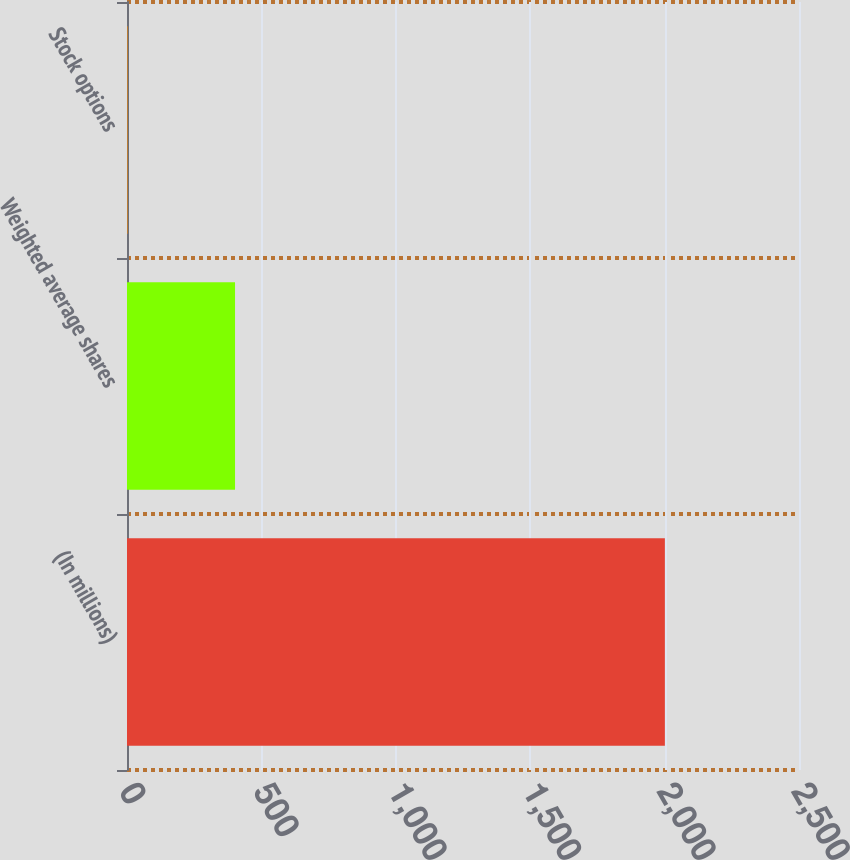<chart> <loc_0><loc_0><loc_500><loc_500><bar_chart><fcel>(In millions)<fcel>Weighted average shares<fcel>Stock options<nl><fcel>2001<fcel>401.88<fcel>2.1<nl></chart> 